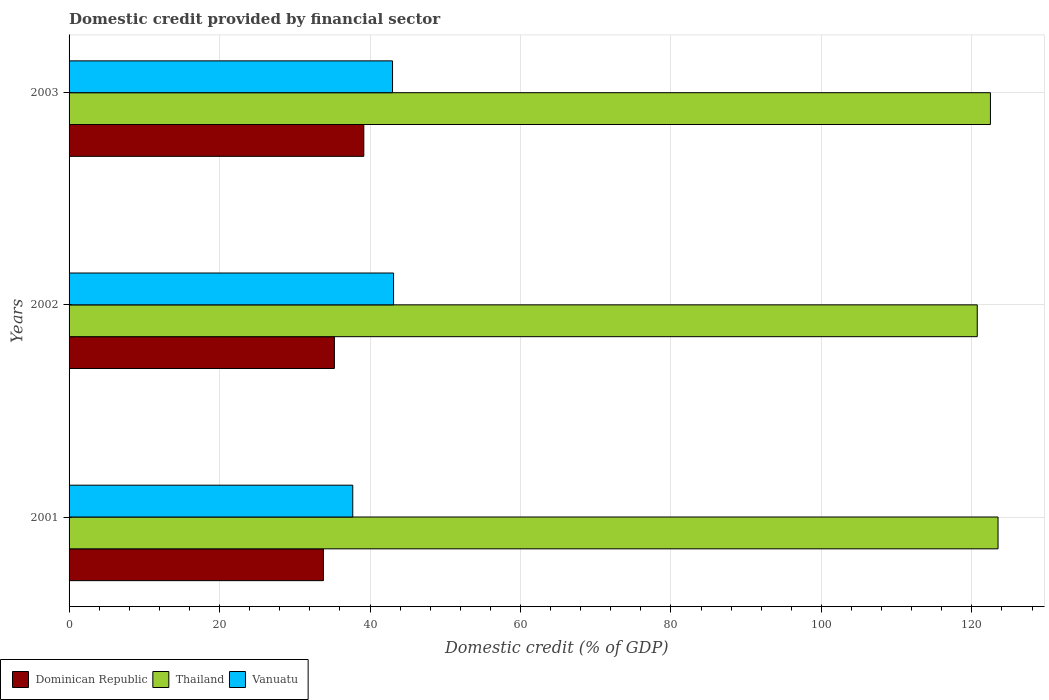How many bars are there on the 2nd tick from the top?
Provide a short and direct response. 3. In how many cases, is the number of bars for a given year not equal to the number of legend labels?
Give a very brief answer. 0. What is the domestic credit in Vanuatu in 2002?
Offer a very short reply. 43.13. Across all years, what is the maximum domestic credit in Thailand?
Make the answer very short. 123.48. Across all years, what is the minimum domestic credit in Vanuatu?
Make the answer very short. 37.71. In which year was the domestic credit in Dominican Republic maximum?
Offer a terse response. 2003. In which year was the domestic credit in Vanuatu minimum?
Offer a very short reply. 2001. What is the total domestic credit in Vanuatu in the graph?
Give a very brief answer. 123.84. What is the difference between the domestic credit in Dominican Republic in 2001 and that in 2002?
Keep it short and to the point. -1.46. What is the difference between the domestic credit in Vanuatu in 2003 and the domestic credit in Thailand in 2002?
Give a very brief answer. -77.72. What is the average domestic credit in Thailand per year?
Provide a short and direct response. 122.22. In the year 2002, what is the difference between the domestic credit in Dominican Republic and domestic credit in Vanuatu?
Ensure brevity in your answer.  -7.87. In how many years, is the domestic credit in Dominican Republic greater than 8 %?
Ensure brevity in your answer.  3. What is the ratio of the domestic credit in Vanuatu in 2001 to that in 2002?
Provide a succinct answer. 0.87. Is the domestic credit in Dominican Republic in 2001 less than that in 2002?
Ensure brevity in your answer.  Yes. What is the difference between the highest and the second highest domestic credit in Thailand?
Your answer should be compact. 1.01. What is the difference between the highest and the lowest domestic credit in Thailand?
Provide a short and direct response. 2.76. In how many years, is the domestic credit in Vanuatu greater than the average domestic credit in Vanuatu taken over all years?
Provide a succinct answer. 2. Is the sum of the domestic credit in Dominican Republic in 2001 and 2003 greater than the maximum domestic credit in Thailand across all years?
Your answer should be very brief. No. What does the 3rd bar from the top in 2002 represents?
Give a very brief answer. Dominican Republic. What does the 2nd bar from the bottom in 2002 represents?
Make the answer very short. Thailand. How many bars are there?
Ensure brevity in your answer.  9. How many years are there in the graph?
Your response must be concise. 3. Are the values on the major ticks of X-axis written in scientific E-notation?
Give a very brief answer. No. Where does the legend appear in the graph?
Give a very brief answer. Bottom left. How many legend labels are there?
Your response must be concise. 3. What is the title of the graph?
Your answer should be very brief. Domestic credit provided by financial sector. What is the label or title of the X-axis?
Give a very brief answer. Domestic credit (% of GDP). What is the Domestic credit (% of GDP) in Dominican Republic in 2001?
Ensure brevity in your answer.  33.81. What is the Domestic credit (% of GDP) in Thailand in 2001?
Provide a succinct answer. 123.48. What is the Domestic credit (% of GDP) in Vanuatu in 2001?
Provide a short and direct response. 37.71. What is the Domestic credit (% of GDP) in Dominican Republic in 2002?
Offer a terse response. 35.27. What is the Domestic credit (% of GDP) in Thailand in 2002?
Your answer should be very brief. 120.72. What is the Domestic credit (% of GDP) of Vanuatu in 2002?
Give a very brief answer. 43.13. What is the Domestic credit (% of GDP) in Dominican Republic in 2003?
Provide a short and direct response. 39.18. What is the Domestic credit (% of GDP) of Thailand in 2003?
Offer a terse response. 122.47. What is the Domestic credit (% of GDP) of Vanuatu in 2003?
Offer a terse response. 43. Across all years, what is the maximum Domestic credit (% of GDP) of Dominican Republic?
Provide a succinct answer. 39.18. Across all years, what is the maximum Domestic credit (% of GDP) in Thailand?
Provide a succinct answer. 123.48. Across all years, what is the maximum Domestic credit (% of GDP) in Vanuatu?
Your answer should be compact. 43.13. Across all years, what is the minimum Domestic credit (% of GDP) of Dominican Republic?
Give a very brief answer. 33.81. Across all years, what is the minimum Domestic credit (% of GDP) in Thailand?
Make the answer very short. 120.72. Across all years, what is the minimum Domestic credit (% of GDP) of Vanuatu?
Give a very brief answer. 37.71. What is the total Domestic credit (% of GDP) of Dominican Republic in the graph?
Offer a very short reply. 108.26. What is the total Domestic credit (% of GDP) in Thailand in the graph?
Give a very brief answer. 366.67. What is the total Domestic credit (% of GDP) in Vanuatu in the graph?
Make the answer very short. 123.84. What is the difference between the Domestic credit (% of GDP) in Dominican Republic in 2001 and that in 2002?
Ensure brevity in your answer.  -1.46. What is the difference between the Domestic credit (% of GDP) of Thailand in 2001 and that in 2002?
Keep it short and to the point. 2.76. What is the difference between the Domestic credit (% of GDP) in Vanuatu in 2001 and that in 2002?
Provide a short and direct response. -5.42. What is the difference between the Domestic credit (% of GDP) in Dominican Republic in 2001 and that in 2003?
Your answer should be compact. -5.37. What is the difference between the Domestic credit (% of GDP) of Thailand in 2001 and that in 2003?
Give a very brief answer. 1.01. What is the difference between the Domestic credit (% of GDP) in Vanuatu in 2001 and that in 2003?
Provide a succinct answer. -5.29. What is the difference between the Domestic credit (% of GDP) of Dominican Republic in 2002 and that in 2003?
Ensure brevity in your answer.  -3.91. What is the difference between the Domestic credit (% of GDP) of Thailand in 2002 and that in 2003?
Give a very brief answer. -1.75. What is the difference between the Domestic credit (% of GDP) in Vanuatu in 2002 and that in 2003?
Offer a terse response. 0.14. What is the difference between the Domestic credit (% of GDP) in Dominican Republic in 2001 and the Domestic credit (% of GDP) in Thailand in 2002?
Offer a terse response. -86.91. What is the difference between the Domestic credit (% of GDP) of Dominican Republic in 2001 and the Domestic credit (% of GDP) of Vanuatu in 2002?
Ensure brevity in your answer.  -9.32. What is the difference between the Domestic credit (% of GDP) of Thailand in 2001 and the Domestic credit (% of GDP) of Vanuatu in 2002?
Provide a short and direct response. 80.35. What is the difference between the Domestic credit (% of GDP) in Dominican Republic in 2001 and the Domestic credit (% of GDP) in Thailand in 2003?
Keep it short and to the point. -88.66. What is the difference between the Domestic credit (% of GDP) of Dominican Republic in 2001 and the Domestic credit (% of GDP) of Vanuatu in 2003?
Offer a very short reply. -9.18. What is the difference between the Domestic credit (% of GDP) of Thailand in 2001 and the Domestic credit (% of GDP) of Vanuatu in 2003?
Your answer should be compact. 80.49. What is the difference between the Domestic credit (% of GDP) in Dominican Republic in 2002 and the Domestic credit (% of GDP) in Thailand in 2003?
Your answer should be very brief. -87.2. What is the difference between the Domestic credit (% of GDP) in Dominican Republic in 2002 and the Domestic credit (% of GDP) in Vanuatu in 2003?
Provide a short and direct response. -7.73. What is the difference between the Domestic credit (% of GDP) in Thailand in 2002 and the Domestic credit (% of GDP) in Vanuatu in 2003?
Keep it short and to the point. 77.72. What is the average Domestic credit (% of GDP) of Dominican Republic per year?
Make the answer very short. 36.09. What is the average Domestic credit (% of GDP) of Thailand per year?
Your response must be concise. 122.22. What is the average Domestic credit (% of GDP) in Vanuatu per year?
Provide a succinct answer. 41.28. In the year 2001, what is the difference between the Domestic credit (% of GDP) in Dominican Republic and Domestic credit (% of GDP) in Thailand?
Provide a short and direct response. -89.67. In the year 2001, what is the difference between the Domestic credit (% of GDP) in Dominican Republic and Domestic credit (% of GDP) in Vanuatu?
Offer a terse response. -3.9. In the year 2001, what is the difference between the Domestic credit (% of GDP) of Thailand and Domestic credit (% of GDP) of Vanuatu?
Give a very brief answer. 85.77. In the year 2002, what is the difference between the Domestic credit (% of GDP) in Dominican Republic and Domestic credit (% of GDP) in Thailand?
Offer a terse response. -85.45. In the year 2002, what is the difference between the Domestic credit (% of GDP) in Dominican Republic and Domestic credit (% of GDP) in Vanuatu?
Your answer should be compact. -7.87. In the year 2002, what is the difference between the Domestic credit (% of GDP) in Thailand and Domestic credit (% of GDP) in Vanuatu?
Keep it short and to the point. 77.58. In the year 2003, what is the difference between the Domestic credit (% of GDP) of Dominican Republic and Domestic credit (% of GDP) of Thailand?
Provide a short and direct response. -83.29. In the year 2003, what is the difference between the Domestic credit (% of GDP) of Dominican Republic and Domestic credit (% of GDP) of Vanuatu?
Ensure brevity in your answer.  -3.82. In the year 2003, what is the difference between the Domestic credit (% of GDP) of Thailand and Domestic credit (% of GDP) of Vanuatu?
Make the answer very short. 79.48. What is the ratio of the Domestic credit (% of GDP) in Dominican Republic in 2001 to that in 2002?
Offer a terse response. 0.96. What is the ratio of the Domestic credit (% of GDP) in Thailand in 2001 to that in 2002?
Your answer should be compact. 1.02. What is the ratio of the Domestic credit (% of GDP) of Vanuatu in 2001 to that in 2002?
Keep it short and to the point. 0.87. What is the ratio of the Domestic credit (% of GDP) in Dominican Republic in 2001 to that in 2003?
Provide a short and direct response. 0.86. What is the ratio of the Domestic credit (% of GDP) of Thailand in 2001 to that in 2003?
Your answer should be very brief. 1.01. What is the ratio of the Domestic credit (% of GDP) of Vanuatu in 2001 to that in 2003?
Your response must be concise. 0.88. What is the ratio of the Domestic credit (% of GDP) of Dominican Republic in 2002 to that in 2003?
Provide a short and direct response. 0.9. What is the ratio of the Domestic credit (% of GDP) in Thailand in 2002 to that in 2003?
Keep it short and to the point. 0.99. What is the ratio of the Domestic credit (% of GDP) in Vanuatu in 2002 to that in 2003?
Your response must be concise. 1. What is the difference between the highest and the second highest Domestic credit (% of GDP) of Dominican Republic?
Offer a very short reply. 3.91. What is the difference between the highest and the second highest Domestic credit (% of GDP) in Thailand?
Your answer should be very brief. 1.01. What is the difference between the highest and the second highest Domestic credit (% of GDP) of Vanuatu?
Your answer should be compact. 0.14. What is the difference between the highest and the lowest Domestic credit (% of GDP) of Dominican Republic?
Offer a terse response. 5.37. What is the difference between the highest and the lowest Domestic credit (% of GDP) in Thailand?
Offer a terse response. 2.76. What is the difference between the highest and the lowest Domestic credit (% of GDP) of Vanuatu?
Your response must be concise. 5.42. 